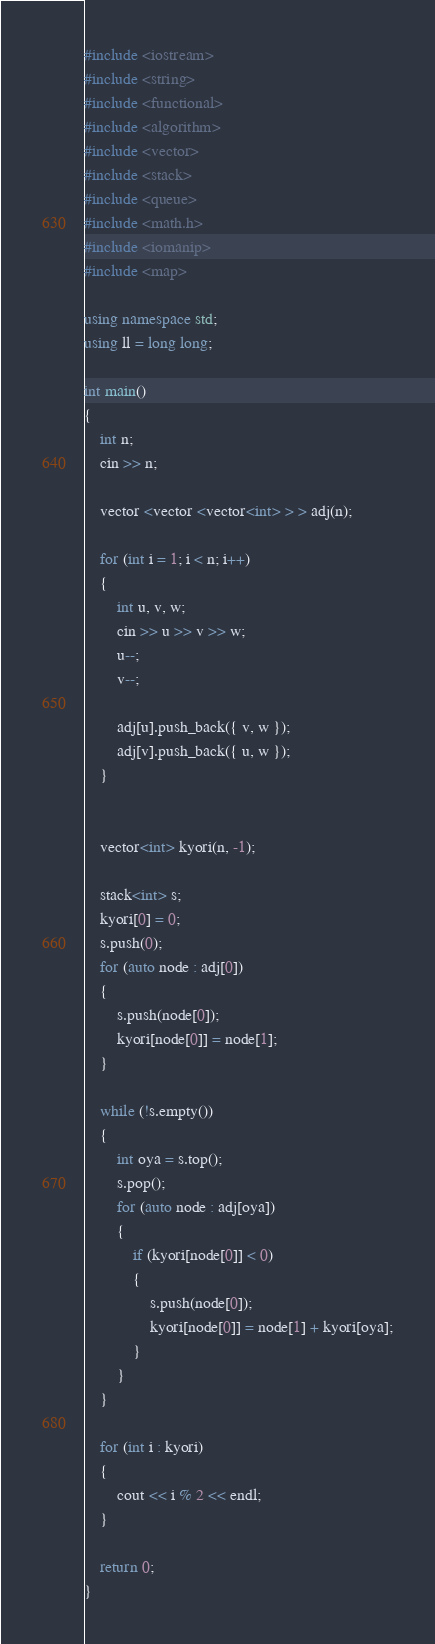<code> <loc_0><loc_0><loc_500><loc_500><_C++_>#include <iostream>
#include <string>
#include <functional>
#include <algorithm>
#include <vector>
#include <stack>
#include <queue>
#include <math.h>
#include <iomanip>
#include <map>

using namespace std;
using ll = long long;

int main()
{
	int n;
	cin >> n;

	vector <vector <vector<int> > > adj(n);

	for (int i = 1; i < n; i++)
	{
		int u, v, w;
		cin >> u >> v >> w;
		u--;
		v--;

		adj[u].push_back({ v, w });
		adj[v].push_back({ u, w });
	}


	vector<int> kyori(n, -1);

	stack<int> s;
	kyori[0] = 0;
	s.push(0);
	for (auto node : adj[0])
	{
		s.push(node[0]);
		kyori[node[0]] = node[1];
	}

	while (!s.empty())
	{
		int oya = s.top();
		s.pop();
		for (auto node : adj[oya])
		{
			if (kyori[node[0]] < 0)
			{
				s.push(node[0]);
				kyori[node[0]] = node[1] + kyori[oya];
			}
		}
	}

	for (int i : kyori)
	{
		cout << i % 2 << endl;
	}

	return 0;
}</code> 